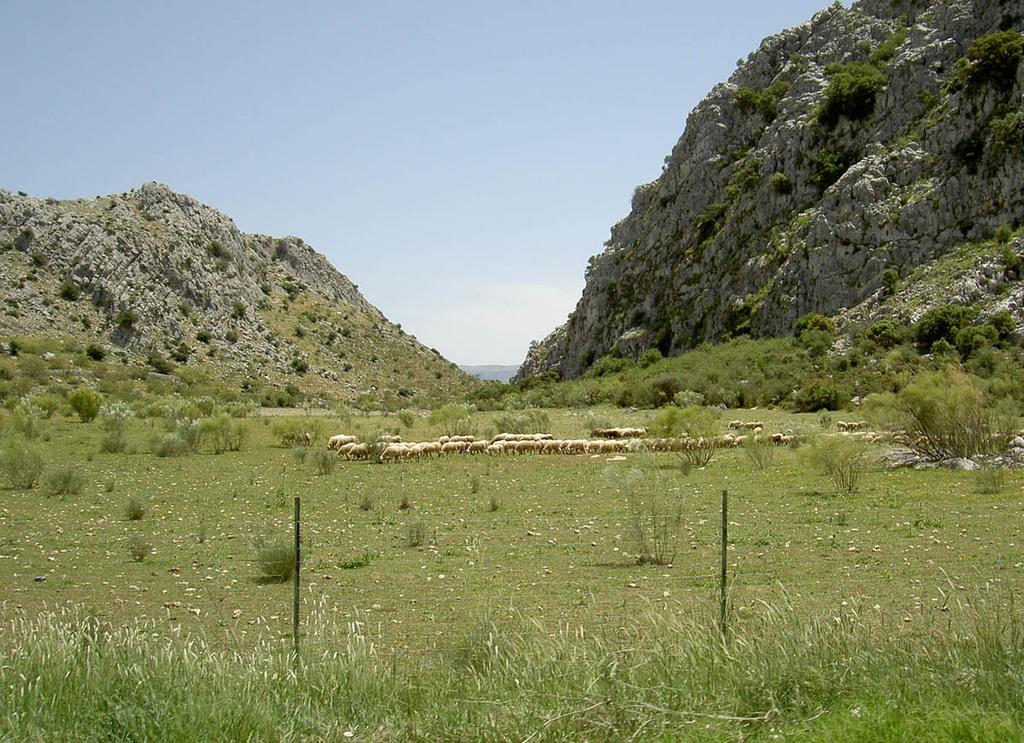What animals are in the center of the image? There are sheeps in the center of the image. What type of vegetation is present in the image? There is grass in the image. What can be seen in the distance in the image? There are mountains in the background of the image. What part of the natural environment is visible in the image? The sky is visible in the image. Where is the office located in the image? There is no office present in the image; it features sheeps, grass, mountains, and the sky. How many people are using the lift in the image? There is no lift present in the image. 